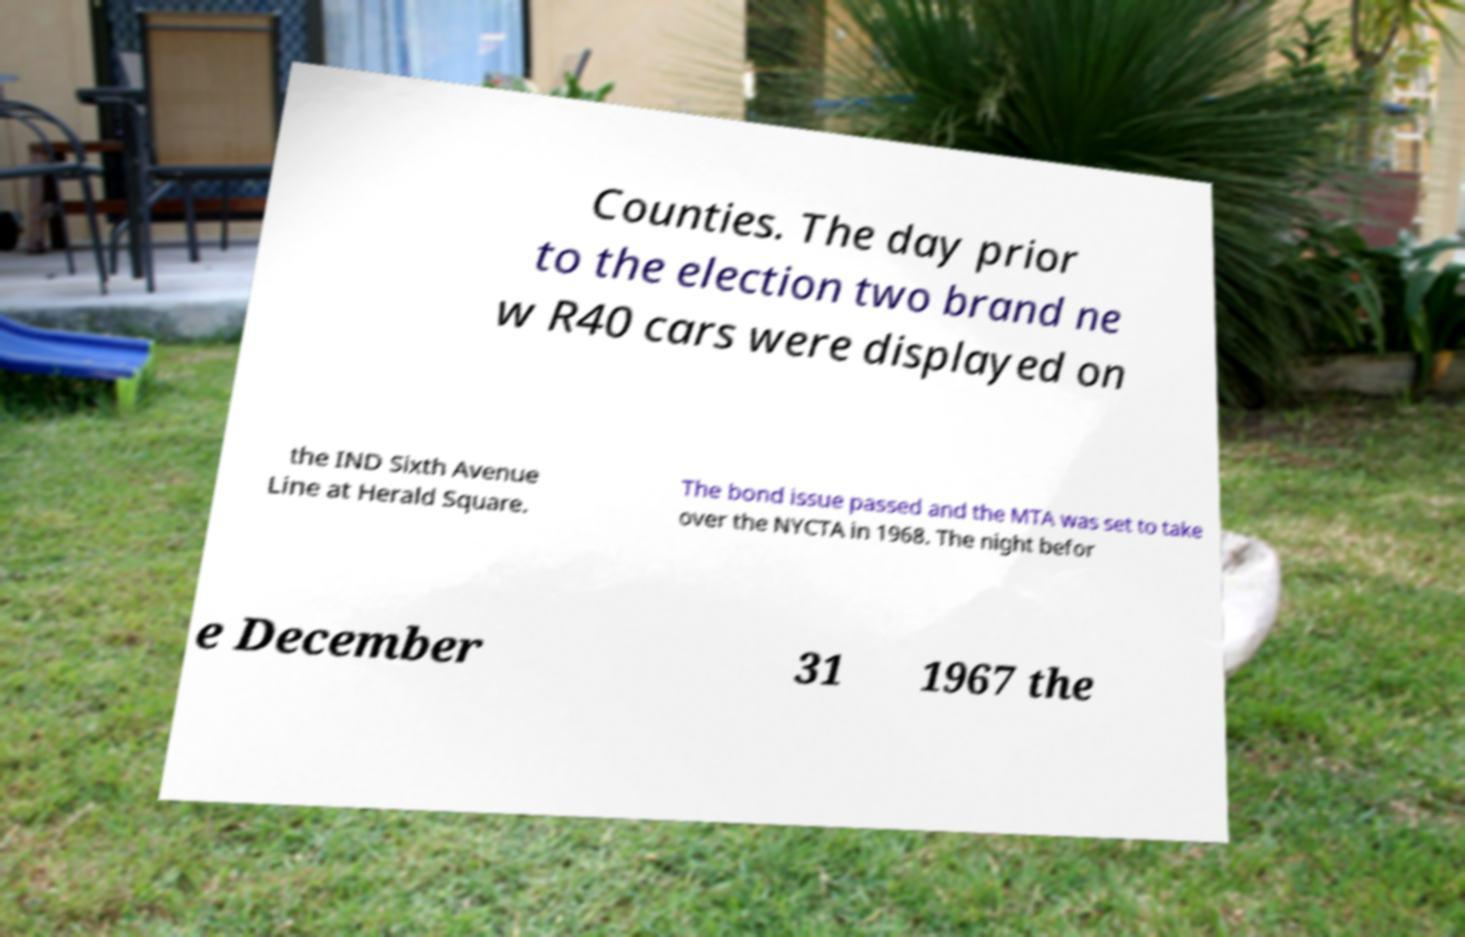Could you assist in decoding the text presented in this image and type it out clearly? Counties. The day prior to the election two brand ne w R40 cars were displayed on the IND Sixth Avenue Line at Herald Square. The bond issue passed and the MTA was set to take over the NYCTA in 1968. The night befor e December 31 1967 the 